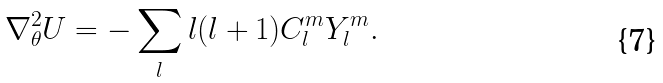<formula> <loc_0><loc_0><loc_500><loc_500>\nabla _ { \theta } ^ { 2 } U = - \sum _ { l } l ( l + 1 ) C _ { l } ^ { m } Y _ { l } ^ { m } .</formula> 